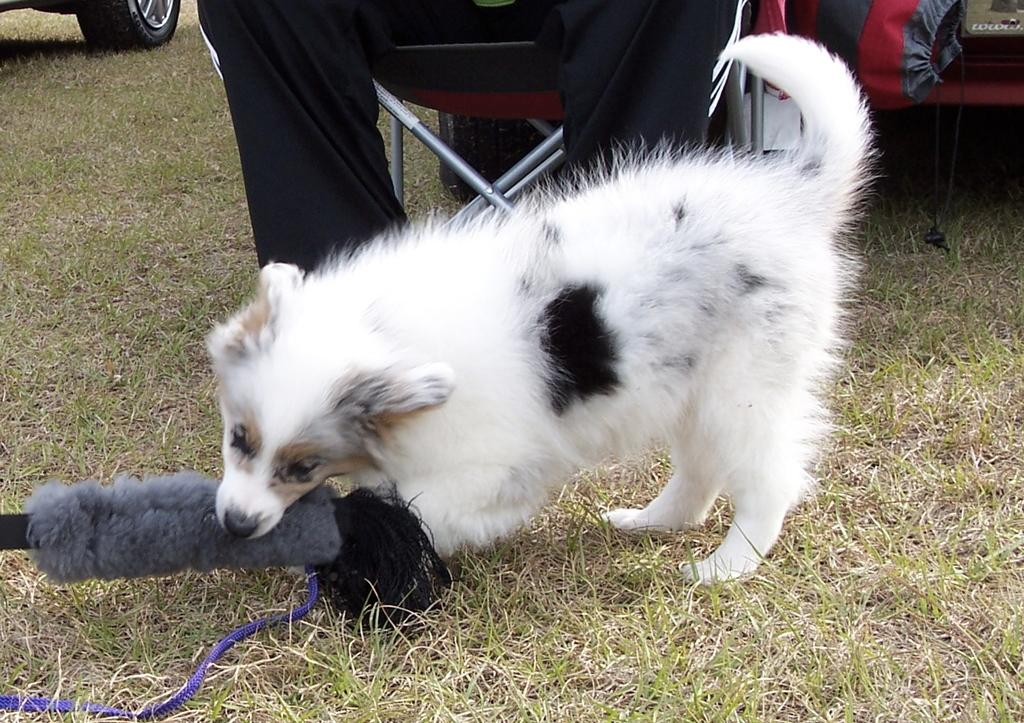What type of animal is in the image? There is a white dog in the image. What is the surface beneath the dog? The dog is on the grass ground. Who else is present in the image? There is a man in the image. What is the man wearing? The man is wearing a black track. What is the man doing in the image? The man is sitting on a chair. What type of hill can be seen in the background of the image? There is no hill visible in the image; it only shows a white dog, a man, and a grassy ground. 